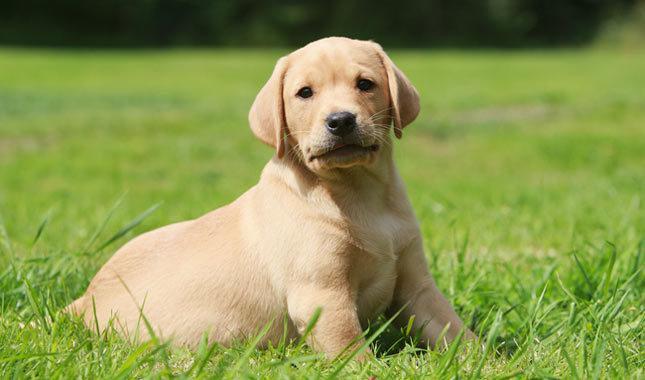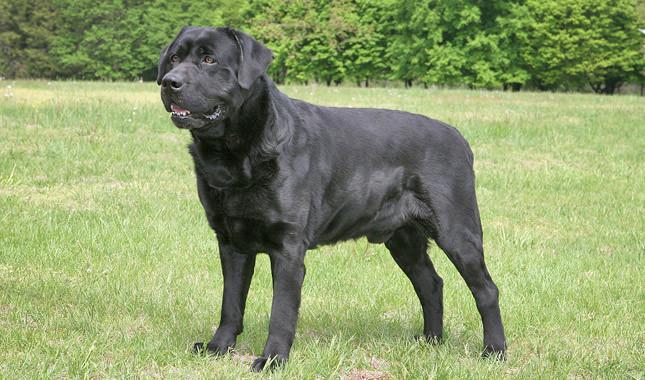The first image is the image on the left, the second image is the image on the right. For the images shown, is this caption "Both images contain a dark colored dog." true? Answer yes or no. No. The first image is the image on the left, the second image is the image on the right. Analyze the images presented: Is the assertion "Both dogs are facing opposite directions." valid? Answer yes or no. Yes. 